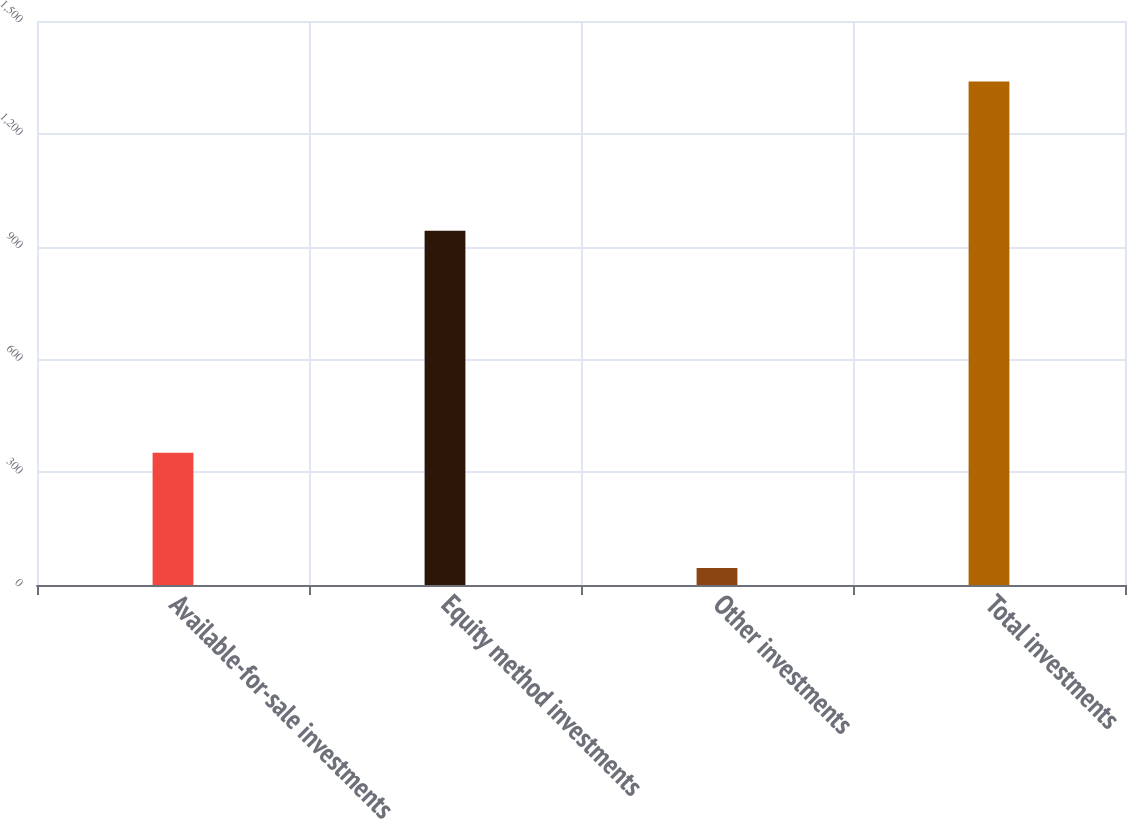Convert chart to OTSL. <chart><loc_0><loc_0><loc_500><loc_500><bar_chart><fcel>Available-for-sale investments<fcel>Equity method investments<fcel>Other investments<fcel>Total investments<nl><fcel>352<fcel>942<fcel>45<fcel>1339<nl></chart> 